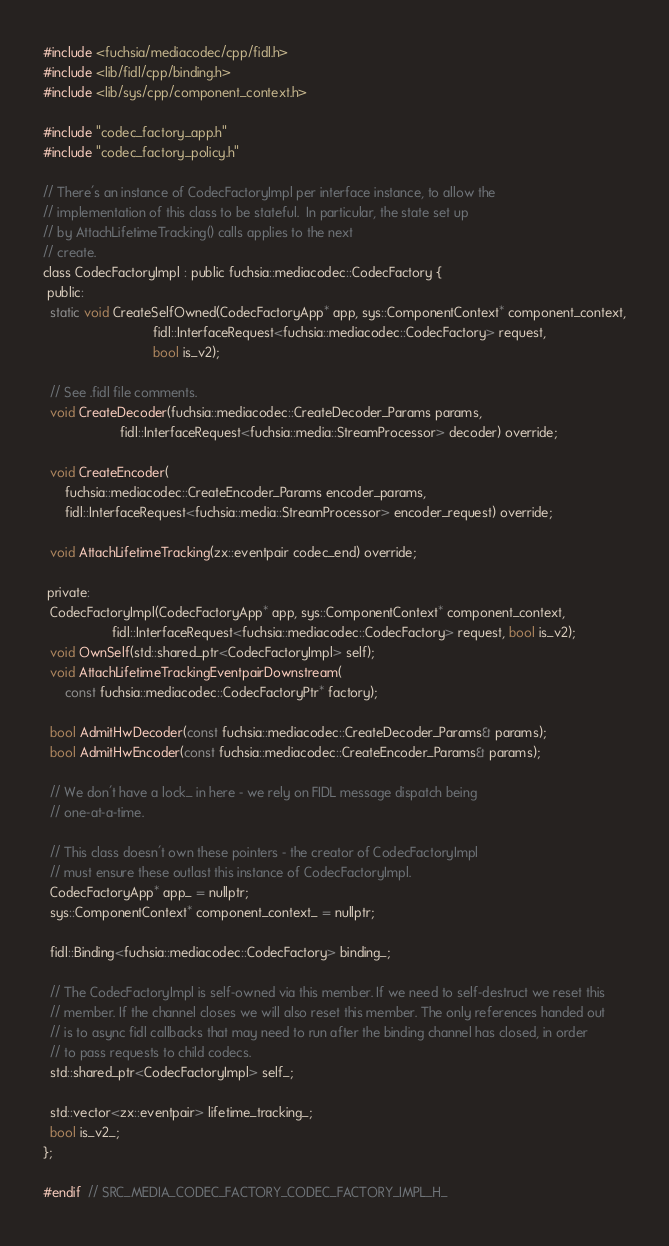<code> <loc_0><loc_0><loc_500><loc_500><_C_>#include <fuchsia/mediacodec/cpp/fidl.h>
#include <lib/fidl/cpp/binding.h>
#include <lib/sys/cpp/component_context.h>

#include "codec_factory_app.h"
#include "codec_factory_policy.h"

// There's an instance of CodecFactoryImpl per interface instance, to allow the
// implementation of this class to be stateful.  In particular, the state set up
// by AttachLifetimeTracking() calls applies to the next
// create.
class CodecFactoryImpl : public fuchsia::mediacodec::CodecFactory {
 public:
  static void CreateSelfOwned(CodecFactoryApp* app, sys::ComponentContext* component_context,
                              fidl::InterfaceRequest<fuchsia::mediacodec::CodecFactory> request,
                              bool is_v2);

  // See .fidl file comments.
  void CreateDecoder(fuchsia::mediacodec::CreateDecoder_Params params,
                     fidl::InterfaceRequest<fuchsia::media::StreamProcessor> decoder) override;

  void CreateEncoder(
      fuchsia::mediacodec::CreateEncoder_Params encoder_params,
      fidl::InterfaceRequest<fuchsia::media::StreamProcessor> encoder_request) override;

  void AttachLifetimeTracking(zx::eventpair codec_end) override;

 private:
  CodecFactoryImpl(CodecFactoryApp* app, sys::ComponentContext* component_context,
                   fidl::InterfaceRequest<fuchsia::mediacodec::CodecFactory> request, bool is_v2);
  void OwnSelf(std::shared_ptr<CodecFactoryImpl> self);
  void AttachLifetimeTrackingEventpairDownstream(
      const fuchsia::mediacodec::CodecFactoryPtr* factory);

  bool AdmitHwDecoder(const fuchsia::mediacodec::CreateDecoder_Params& params);
  bool AdmitHwEncoder(const fuchsia::mediacodec::CreateEncoder_Params& params);

  // We don't have a lock_ in here - we rely on FIDL message dispatch being
  // one-at-a-time.

  // This class doesn't own these pointers - the creator of CodecFactoryImpl
  // must ensure these outlast this instance of CodecFactoryImpl.
  CodecFactoryApp* app_ = nullptr;
  sys::ComponentContext* component_context_ = nullptr;

  fidl::Binding<fuchsia::mediacodec::CodecFactory> binding_;

  // The CodecFactoryImpl is self-owned via this member. If we need to self-destruct we reset this
  // member. If the channel closes we will also reset this member. The only references handed out
  // is to async fidl callbacks that may need to run after the binding channel has closed, in order
  // to pass requests to child codecs.
  std::shared_ptr<CodecFactoryImpl> self_;

  std::vector<zx::eventpair> lifetime_tracking_;
  bool is_v2_;
};

#endif  // SRC_MEDIA_CODEC_FACTORY_CODEC_FACTORY_IMPL_H_
</code> 